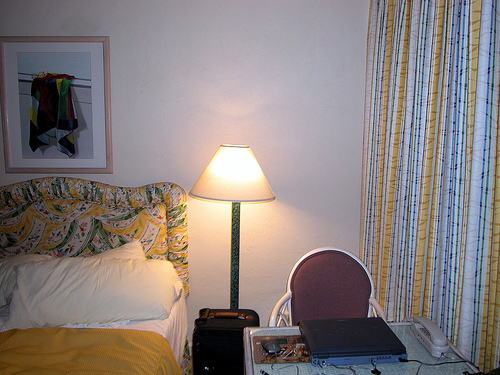<image>
Is the wall behind the bed? Yes. From this viewpoint, the wall is positioned behind the bed, with the bed partially or fully occluding the wall. 